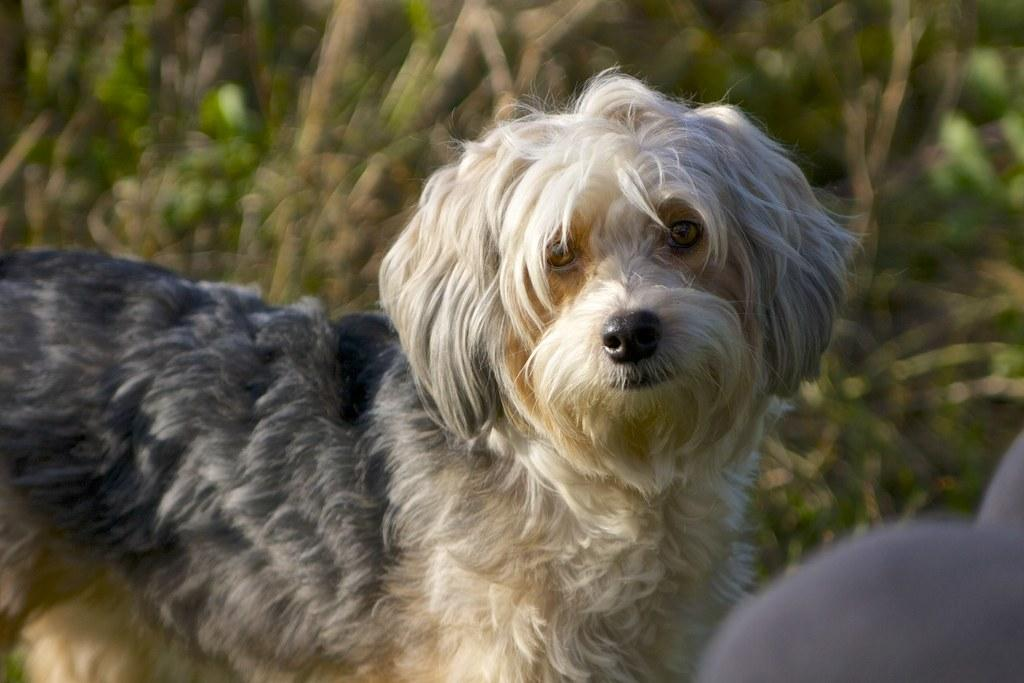What is the main subject of the image? There is a dog in the center of the image. Can you describe the background of the image? The background of the image is blurry. What type of art is displayed on the wall behind the dog in the image? There is no art or wall visible in the image; the background is blurry. How much sugar is in the dog's food bowl in the image? There is no food bowl or sugar present in the image; it only features a dog in the center. 